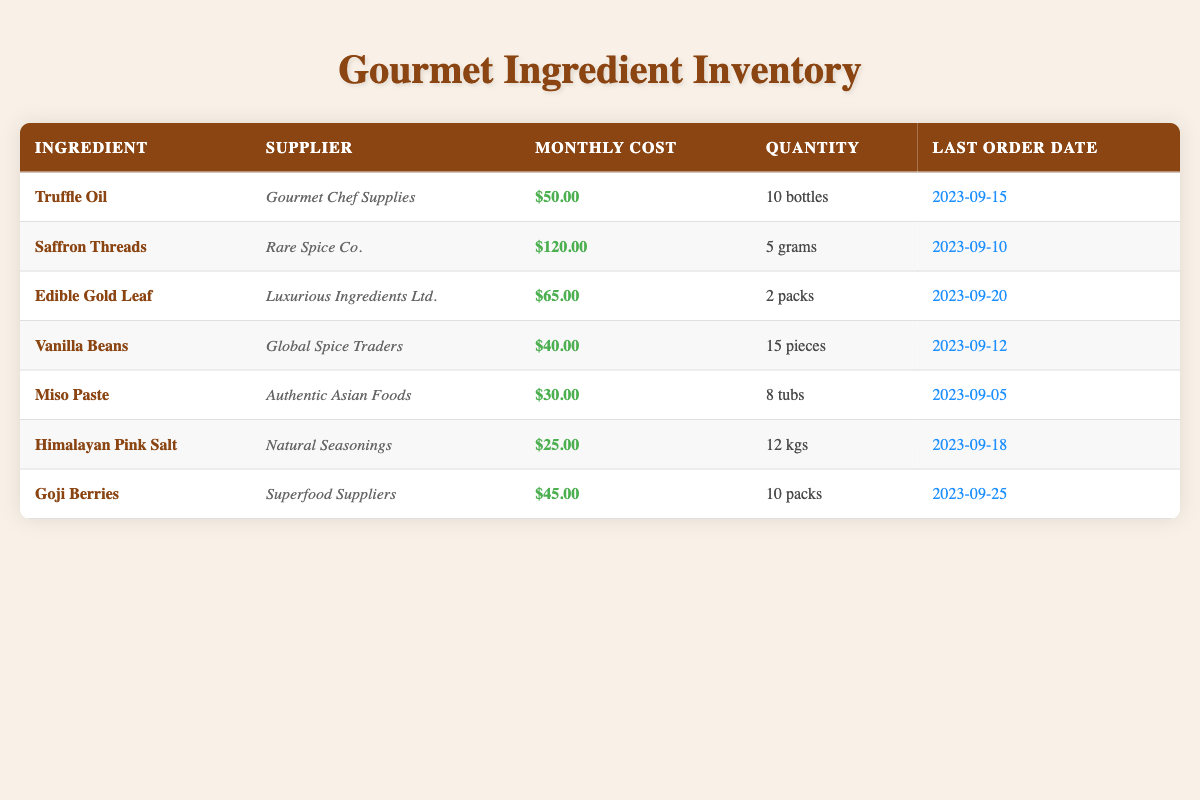What is the monthly cost of Saffron Threads? The table lists Saffron Threads under the ingredient column with a monthly cost of $120.00 noted in the corresponding column.
Answer: $120.00 How many bottles of Truffle Oil are in stock? The table shows Truffle Oil with a quantity of 10 bottles listed in the quantity column.
Answer: 10 bottles Which ingredient has the highest monthly cost? By comparing the monthly costs of all ingredients, Saffron Threads has the highest monthly cost at $120.00.
Answer: Saffron Threads What is the total monthly cost of all ingredients combined? To find the total, we sum the monthly costs: 50 + 120 + 65 + 40 + 30 + 25 + 45 = 375. Therefore, the total monthly cost is $375.00.
Answer: $375.00 Is the last order date for Miso Paste after that of Vanilla Beans? Miso Paste's last order date is 2023-09-05, and Vanilla Beans' last order date is 2023-09-12. Since 2023-09-05 is before 2023-09-12, the statement is false.
Answer: No How many grams of Saffron Threads were ordered last month? Saffron Threads is noted to be in stock with a quantity of 5 grams in the table, thus confirming that this is the amount ordered last month.
Answer: 5 grams What is the average monthly cost of the ingredients? Calculating the average involves adding all monthly costs (50 + 120 + 65 + 40 + 30 + 25 + 45 = 375) and dividing by the number of ingredients (7): 375 / 7 is approximately 53.57.
Answer: 53.57 Does Edible Gold Leaf have a lower quantity than Goji Berries? Edible Gold Leaf has a quantity of 2 packs and Goji Berries has a quantity of 10 packs. Since 2 is less than 10, this statement is true.
Answer: Yes How many ingredients have a monthly cost less than $50? The costs below $50 are for Himalayan Pink Salt ($25), and Miso Paste ($30), totaling 2 ingredients that meet this criterion.
Answer: 2 ingredients 